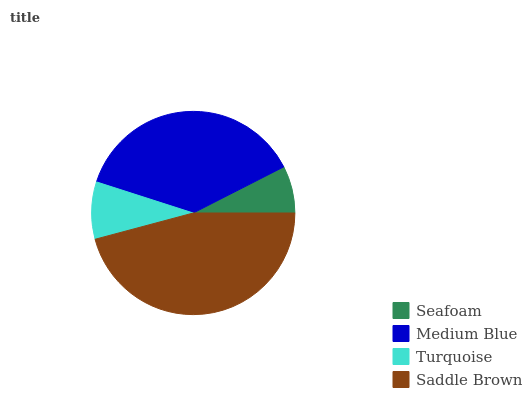Is Seafoam the minimum?
Answer yes or no. Yes. Is Saddle Brown the maximum?
Answer yes or no. Yes. Is Medium Blue the minimum?
Answer yes or no. No. Is Medium Blue the maximum?
Answer yes or no. No. Is Medium Blue greater than Seafoam?
Answer yes or no. Yes. Is Seafoam less than Medium Blue?
Answer yes or no. Yes. Is Seafoam greater than Medium Blue?
Answer yes or no. No. Is Medium Blue less than Seafoam?
Answer yes or no. No. Is Medium Blue the high median?
Answer yes or no. Yes. Is Turquoise the low median?
Answer yes or no. Yes. Is Seafoam the high median?
Answer yes or no. No. Is Seafoam the low median?
Answer yes or no. No. 